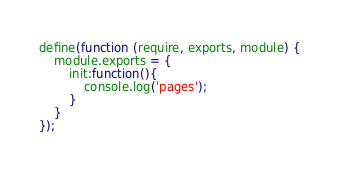<code> <loc_0><loc_0><loc_500><loc_500><_JavaScript_>define(function (require, exports, module) {
    module.exports = {
        init:function(){
            console.log('pages');
        }
    }
});
</code> 